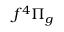Convert formula to latex. <formula><loc_0><loc_0><loc_500><loc_500>f ^ { 4 } \Pi _ { g }</formula> 